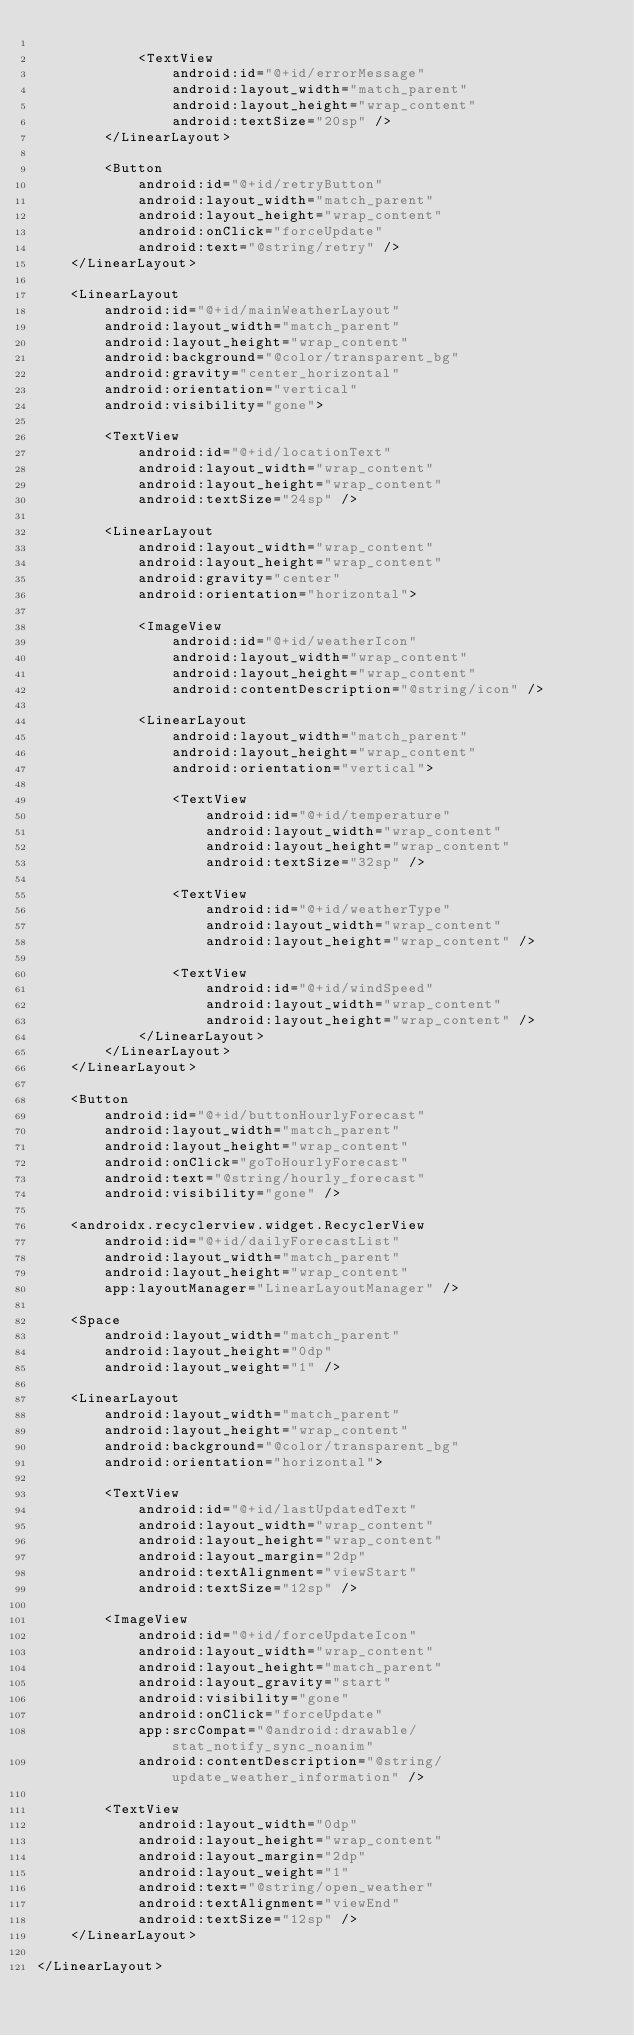<code> <loc_0><loc_0><loc_500><loc_500><_XML_>
            <TextView
                android:id="@+id/errorMessage"
                android:layout_width="match_parent"
                android:layout_height="wrap_content"
                android:textSize="20sp" />
        </LinearLayout>

        <Button
            android:id="@+id/retryButton"
            android:layout_width="match_parent"
            android:layout_height="wrap_content"
            android:onClick="forceUpdate"
            android:text="@string/retry" />
    </LinearLayout>

    <LinearLayout
        android:id="@+id/mainWeatherLayout"
        android:layout_width="match_parent"
        android:layout_height="wrap_content"
        android:background="@color/transparent_bg"
        android:gravity="center_horizontal"
        android:orientation="vertical"
        android:visibility="gone">

        <TextView
            android:id="@+id/locationText"
            android:layout_width="wrap_content"
            android:layout_height="wrap_content"
            android:textSize="24sp" />

        <LinearLayout
            android:layout_width="wrap_content"
            android:layout_height="wrap_content"
            android:gravity="center"
            android:orientation="horizontal">

            <ImageView
                android:id="@+id/weatherIcon"
                android:layout_width="wrap_content"
                android:layout_height="wrap_content"
                android:contentDescription="@string/icon" />

            <LinearLayout
                android:layout_width="match_parent"
                android:layout_height="wrap_content"
                android:orientation="vertical">

                <TextView
                    android:id="@+id/temperature"
                    android:layout_width="wrap_content"
                    android:layout_height="wrap_content"
                    android:textSize="32sp" />

                <TextView
                    android:id="@+id/weatherType"
                    android:layout_width="wrap_content"
                    android:layout_height="wrap_content" />

                <TextView
                    android:id="@+id/windSpeed"
                    android:layout_width="wrap_content"
                    android:layout_height="wrap_content" />
            </LinearLayout>
        </LinearLayout>
    </LinearLayout>

    <Button
        android:id="@+id/buttonHourlyForecast"
        android:layout_width="match_parent"
        android:layout_height="wrap_content"
        android:onClick="goToHourlyForecast"
        android:text="@string/hourly_forecast"
        android:visibility="gone" />

    <androidx.recyclerview.widget.RecyclerView
        android:id="@+id/dailyForecastList"
        android:layout_width="match_parent"
        android:layout_height="wrap_content"
        app:layoutManager="LinearLayoutManager" />

    <Space
        android:layout_width="match_parent"
        android:layout_height="0dp"
        android:layout_weight="1" />

    <LinearLayout
        android:layout_width="match_parent"
        android:layout_height="wrap_content"
        android:background="@color/transparent_bg"
        android:orientation="horizontal">

        <TextView
            android:id="@+id/lastUpdatedText"
            android:layout_width="wrap_content"
            android:layout_height="wrap_content"
            android:layout_margin="2dp"
            android:textAlignment="viewStart"
            android:textSize="12sp" />

        <ImageView
            android:id="@+id/forceUpdateIcon"
            android:layout_width="wrap_content"
            android:layout_height="match_parent"
            android:layout_gravity="start"
            android:visibility="gone"
            android:onClick="forceUpdate"
            app:srcCompat="@android:drawable/stat_notify_sync_noanim"
            android:contentDescription="@string/update_weather_information" />

        <TextView
            android:layout_width="0dp"
            android:layout_height="wrap_content"
            android:layout_margin="2dp"
            android:layout_weight="1"
            android:text="@string/open_weather"
            android:textAlignment="viewEnd"
            android:textSize="12sp" />
    </LinearLayout>

</LinearLayout></code> 